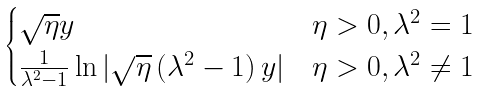Convert formula to latex. <formula><loc_0><loc_0><loc_500><loc_500>\begin{cases} \sqrt { \eta } y & \eta > 0 , \lambda ^ { 2 } = 1 \\ \frac { 1 } { \lambda ^ { 2 } - 1 } \ln | \sqrt { \eta } \left ( \lambda ^ { 2 } - 1 \right ) y | & \eta > 0 , \lambda ^ { 2 } \neq 1 \\ \end{cases}</formula> 